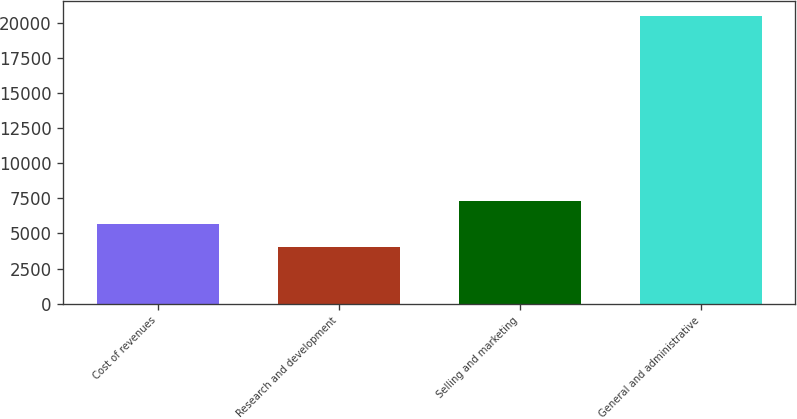Convert chart. <chart><loc_0><loc_0><loc_500><loc_500><bar_chart><fcel>Cost of revenues<fcel>Research and development<fcel>Selling and marketing<fcel>General and administrative<nl><fcel>5660.3<fcel>4011<fcel>7309.6<fcel>20504<nl></chart> 